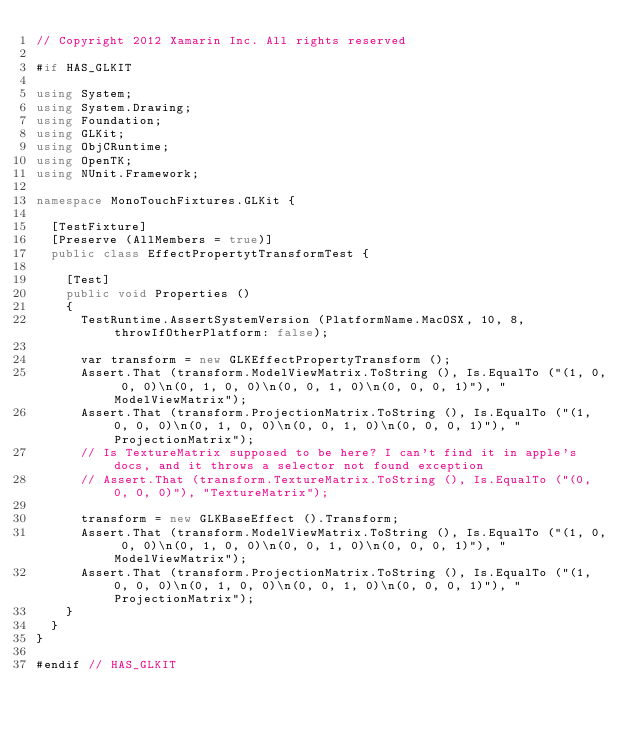Convert code to text. <code><loc_0><loc_0><loc_500><loc_500><_C#_>// Copyright 2012 Xamarin Inc. All rights reserved

#if HAS_GLKIT

using System;
using System.Drawing;
using Foundation;
using GLKit;
using ObjCRuntime;
using OpenTK;
using NUnit.Framework;

namespace MonoTouchFixtures.GLKit {
	
	[TestFixture]
	[Preserve (AllMembers = true)]
	public class EffectPropertytTransformTest {
		
		[Test]
		public void Properties ()
		{
			TestRuntime.AssertSystemVersion (PlatformName.MacOSX, 10, 8, throwIfOtherPlatform: false);

			var transform = new GLKEffectPropertyTransform ();
			Assert.That (transform.ModelViewMatrix.ToString (), Is.EqualTo ("(1, 0, 0, 0)\n(0, 1, 0, 0)\n(0, 0, 1, 0)\n(0, 0, 0, 1)"), "ModelViewMatrix");
			Assert.That (transform.ProjectionMatrix.ToString (), Is.EqualTo ("(1, 0, 0, 0)\n(0, 1, 0, 0)\n(0, 0, 1, 0)\n(0, 0, 0, 1)"), "ProjectionMatrix");
			// Is TextureMatrix supposed to be here? I can't find it in apple's docs, and it throws a selector not found exception
			// Assert.That (transform.TextureMatrix.ToString (), Is.EqualTo ("(0, 0, 0, 0)"), "TextureMatrix");

			transform = new GLKBaseEffect ().Transform;
			Assert.That (transform.ModelViewMatrix.ToString (), Is.EqualTo ("(1, 0, 0, 0)\n(0, 1, 0, 0)\n(0, 0, 1, 0)\n(0, 0, 0, 1)"), "ModelViewMatrix");
			Assert.That (transform.ProjectionMatrix.ToString (), Is.EqualTo ("(1, 0, 0, 0)\n(0, 1, 0, 0)\n(0, 0, 1, 0)\n(0, 0, 0, 1)"), "ProjectionMatrix");
		}
	}
}

#endif // HAS_GLKIT
</code> 